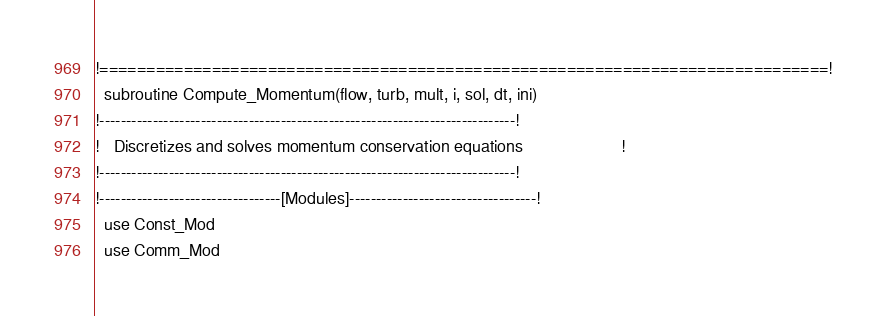Convert code to text. <code><loc_0><loc_0><loc_500><loc_500><_FORTRAN_>!==============================================================================!
  subroutine Compute_Momentum(flow, turb, mult, i, sol, dt, ini)
!------------------------------------------------------------------------------!
!   Discretizes and solves momentum conservation equations                     !
!------------------------------------------------------------------------------!
!----------------------------------[Modules]-----------------------------------!
  use Const_Mod
  use Comm_Mod</code> 